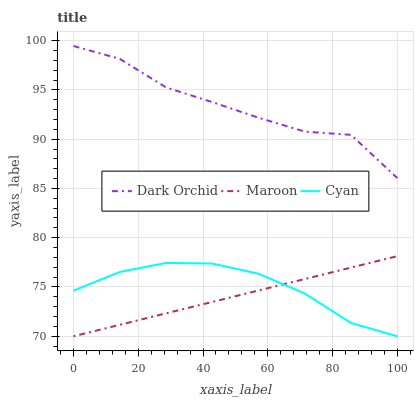Does Dark Orchid have the minimum area under the curve?
Answer yes or no. No. Does Maroon have the maximum area under the curve?
Answer yes or no. No. Is Dark Orchid the smoothest?
Answer yes or no. No. Is Maroon the roughest?
Answer yes or no. No. Does Dark Orchid have the lowest value?
Answer yes or no. No. Does Maroon have the highest value?
Answer yes or no. No. Is Maroon less than Dark Orchid?
Answer yes or no. Yes. Is Dark Orchid greater than Cyan?
Answer yes or no. Yes. Does Maroon intersect Dark Orchid?
Answer yes or no. No. 